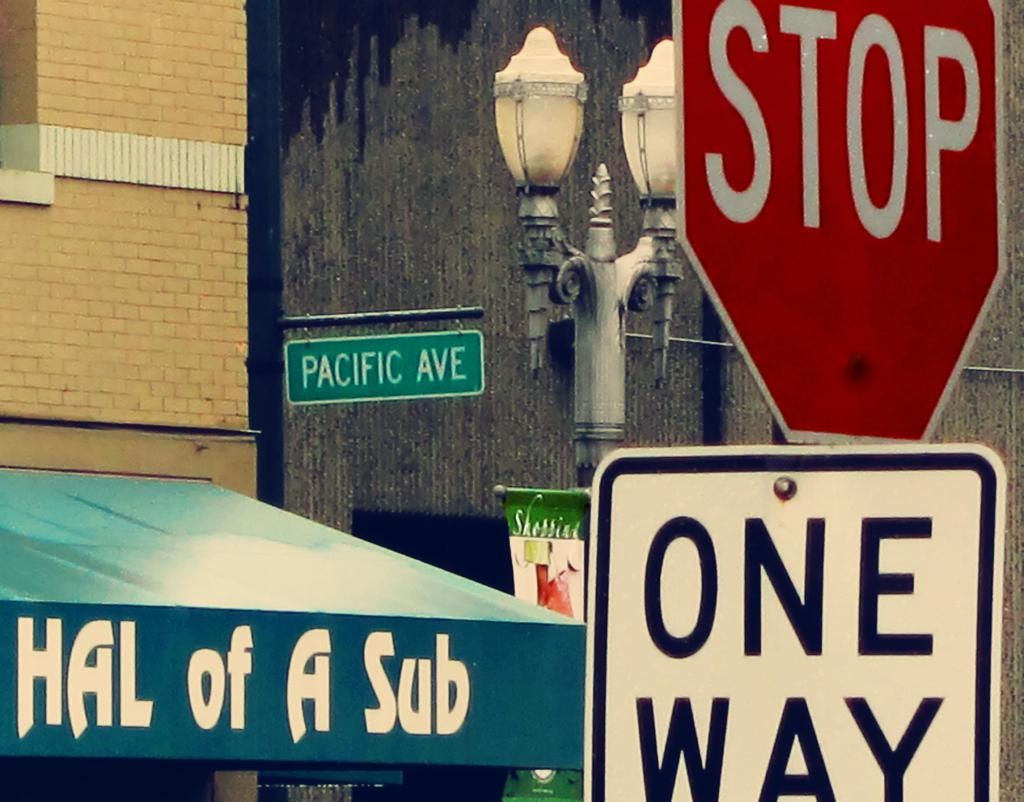Provide a one-sentence caption for the provided image. A green awning stating "Hal of a Sub" is next to a street sign for Pacific Ave, as well as a stop sign and a one way sign. 